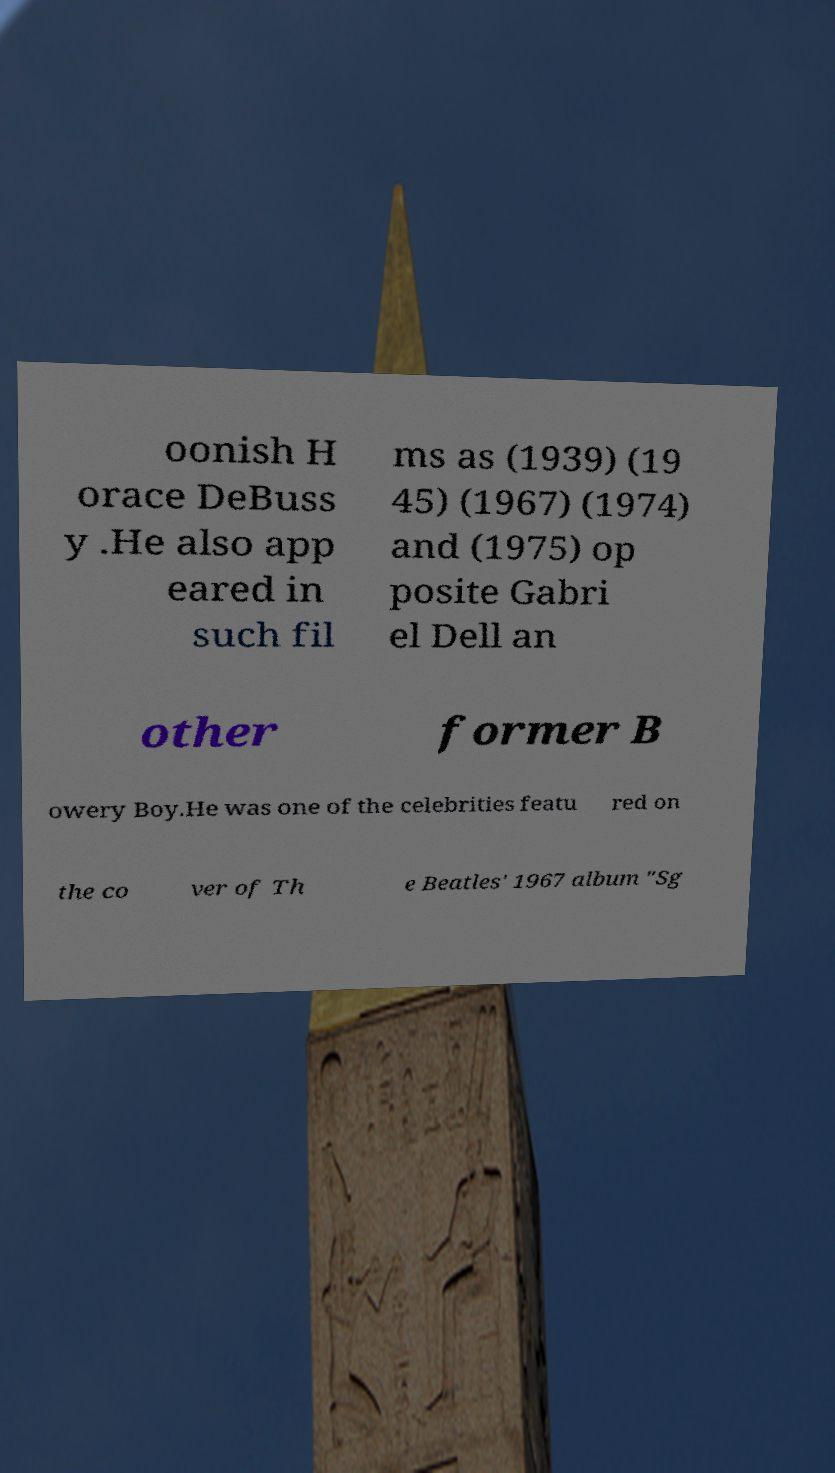What messages or text are displayed in this image? I need them in a readable, typed format. oonish H orace DeBuss y .He also app eared in such fil ms as (1939) (19 45) (1967) (1974) and (1975) op posite Gabri el Dell an other former B owery Boy.He was one of the celebrities featu red on the co ver of Th e Beatles' 1967 album "Sg 